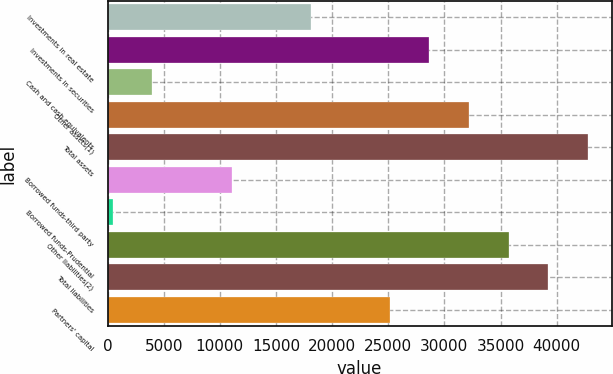<chart> <loc_0><loc_0><loc_500><loc_500><bar_chart><fcel>Investments in real estate<fcel>Investments in securities<fcel>Cash and cash equivalents<fcel>Other assets(1)<fcel>Total assets<fcel>Borrowed funds-third party<fcel>Borrowed funds-Prudential<fcel>Other liabilities(2)<fcel>Total liabilities<fcel>Partners' capital<nl><fcel>18097.5<fcel>28671<fcel>3999.5<fcel>32195.5<fcel>42769<fcel>11048.5<fcel>475<fcel>35720<fcel>39244.5<fcel>25146.5<nl></chart> 